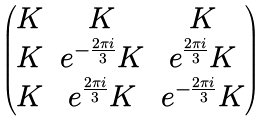<formula> <loc_0><loc_0><loc_500><loc_500>\begin{pmatrix} K & K & K \\ K & e ^ { - \frac { 2 \pi i } { 3 } } K & e ^ { \frac { 2 \pi i } { 3 } } K \\ K & e ^ { \frac { 2 \pi i } { 3 } } K & e ^ { - \frac { 2 \pi i } { 3 } } K \end{pmatrix}</formula> 